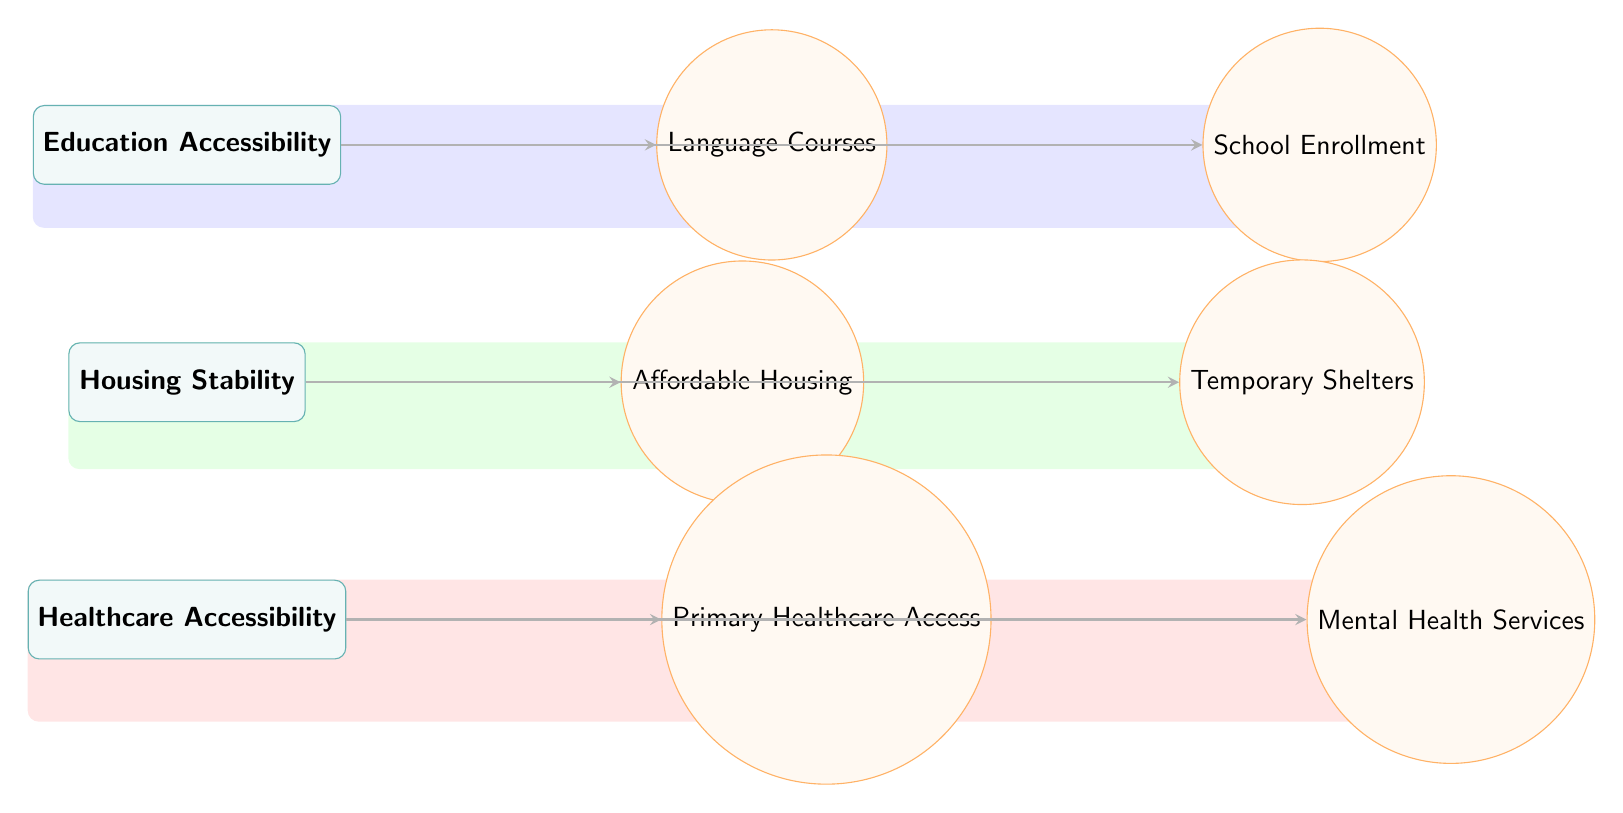What is the top category in the diagram? The top category is labeled 'Education Accessibility', and it is the first node listed in the hierarchy of categories.
Answer: Education Accessibility How many categories are represented in the diagram? There are three categories depicted: Education Accessibility, Housing Stability, and Healthcare Accessibility. Counting them gives us a total of three.
Answer: 3 What metric is connected to Housing Stability? 'Affordable Housing' is one of the metrics directly connected to the category of Housing Stability, as indicated by the arrow showing the relationship.
Answer: Affordable Housing Which category does 'Mental Health Services' belong to? 'Mental Health Services' is linked to the 'Healthcare Accessibility' category, as shown in the diagram where the metric is directly under that category.
Answer: Healthcare Accessibility What is the relationship between 'School Enrollment' and 'Education Accessibility'? 'School Enrollment' is a metric that is linked to the 'Education Accessibility' category, indicated by the arrow connecting these two nodes in the diagram.
Answer: Direct connection How many metrics are there in total for Healthcare Accessibility? There are two metrics under the Healthcare Accessibility category: 'Primary Healthcare Access' and 'Mental Health Services', making a total of two.
Answer: 2 What color represents the Housing Stability category in the background? The background for the Housing Stability category is filled with a green color, as shown in the diagram where it highlights that specific section.
Answer: Green Which metric is directly related to language in the diagram? The metric 'Language Courses' is associated with the Education Accessibility category and is highlighted as the first metric related to language.
Answer: Language Courses What two metrics are associated with the Healthcare Accessibility category? The two metrics associated with Healthcare Accessibility are 'Primary Healthcare Access' and 'Mental Health Services', as both are shown as directly connected to that category.
Answer: Primary Healthcare Access, Mental Health Services What shape is used to represent the metrics in the diagram? The metrics are represented using circles, as indicated by the circular shape specified for the metrics in the diagram's style definition.
Answer: Circle 